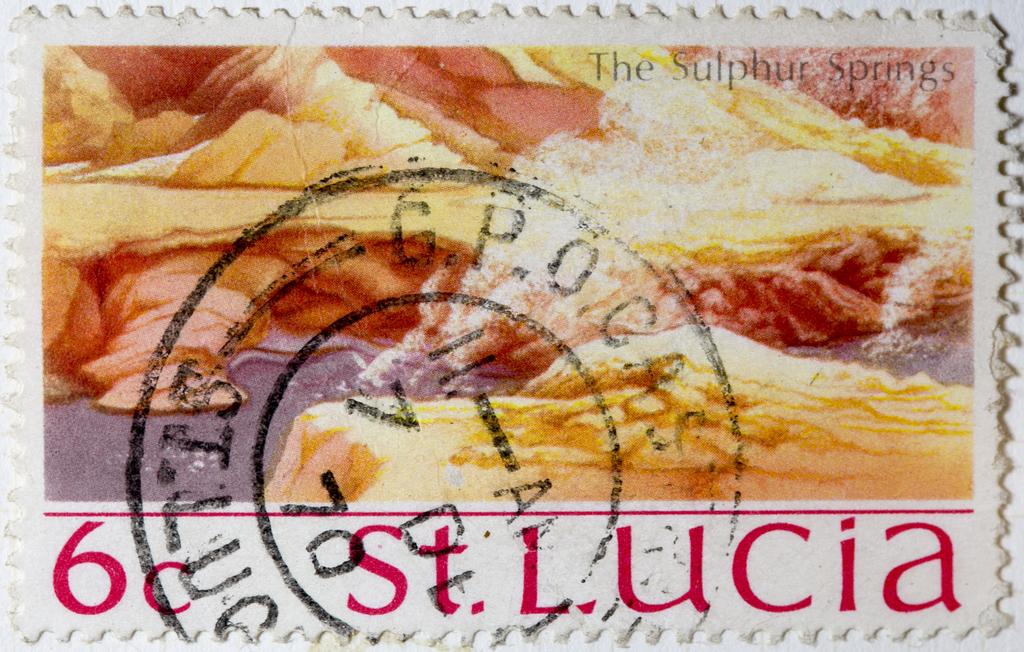What is the main subject of the image? The main subject of the image is a post stamp. What type of yak can be seen sounding the alarm in the image? There is no yak or alarm present in the image; it only features a post stamp. 